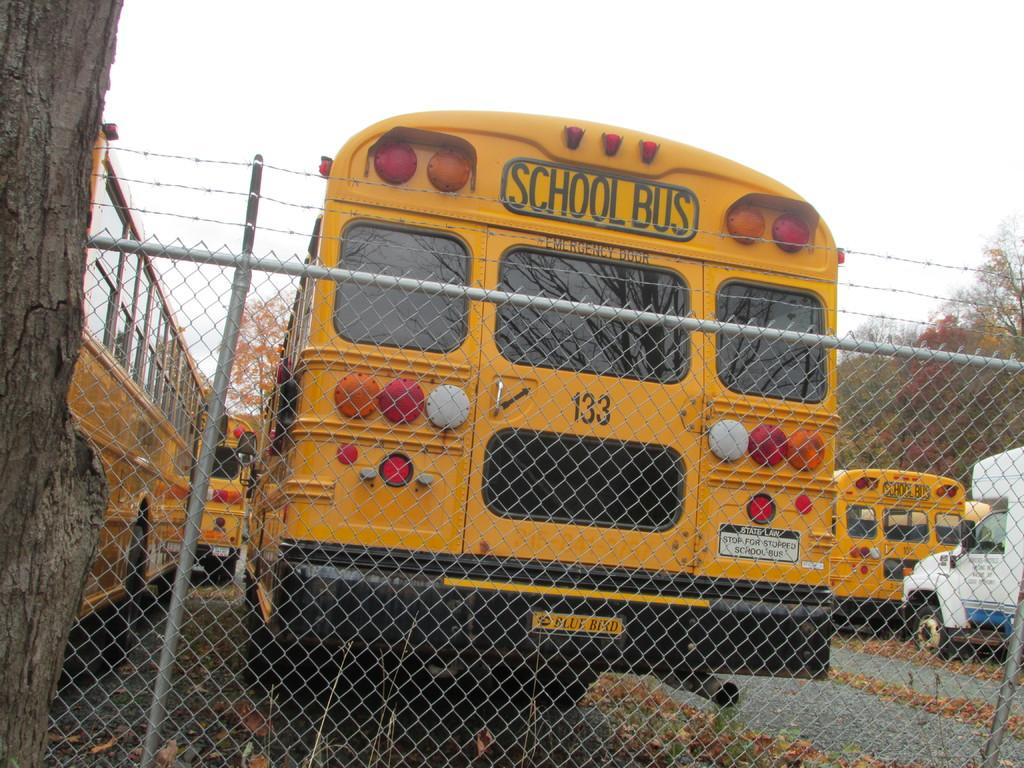Provide a one-sentence caption for the provided image. A school bus has a number 133 on its back door. 